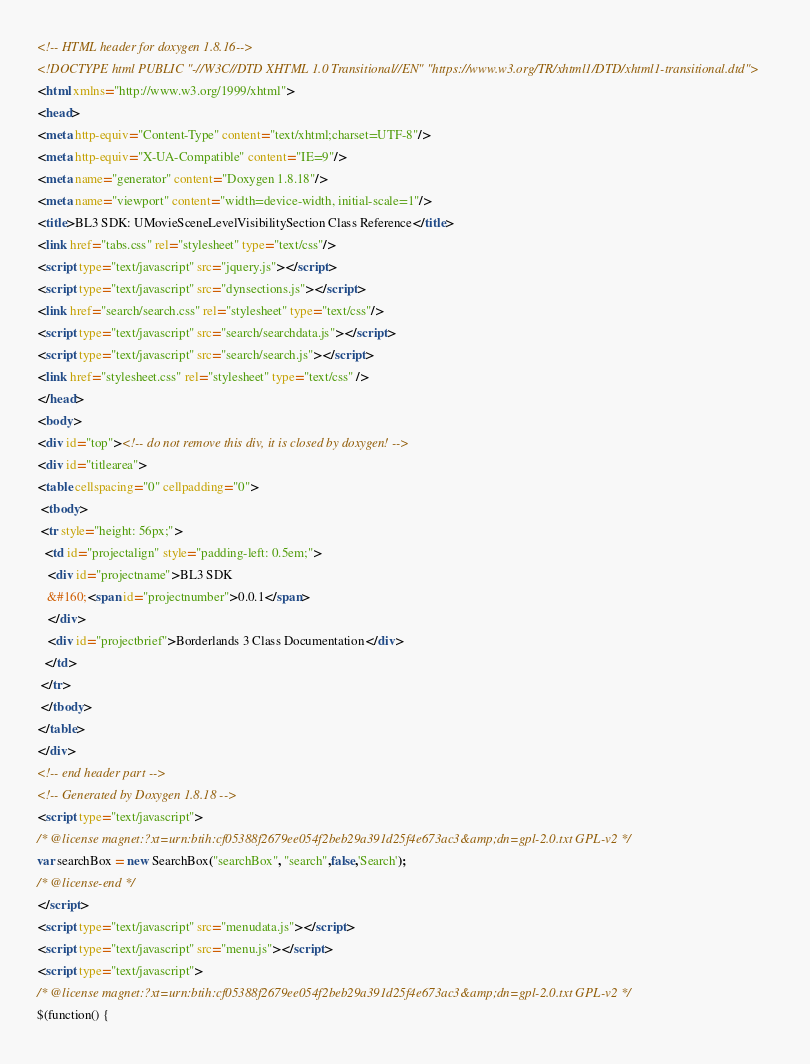<code> <loc_0><loc_0><loc_500><loc_500><_HTML_><!-- HTML header for doxygen 1.8.16-->
<!DOCTYPE html PUBLIC "-//W3C//DTD XHTML 1.0 Transitional//EN" "https://www.w3.org/TR/xhtml1/DTD/xhtml1-transitional.dtd">
<html xmlns="http://www.w3.org/1999/xhtml">
<head>
<meta http-equiv="Content-Type" content="text/xhtml;charset=UTF-8"/>
<meta http-equiv="X-UA-Compatible" content="IE=9"/>
<meta name="generator" content="Doxygen 1.8.18"/>
<meta name="viewport" content="width=device-width, initial-scale=1"/>
<title>BL3 SDK: UMovieSceneLevelVisibilitySection Class Reference</title>
<link href="tabs.css" rel="stylesheet" type="text/css"/>
<script type="text/javascript" src="jquery.js"></script>
<script type="text/javascript" src="dynsections.js"></script>
<link href="search/search.css" rel="stylesheet" type="text/css"/>
<script type="text/javascript" src="search/searchdata.js"></script>
<script type="text/javascript" src="search/search.js"></script>
<link href="stylesheet.css" rel="stylesheet" type="text/css" />
</head>
<body>
<div id="top"><!-- do not remove this div, it is closed by doxygen! -->
<div id="titlearea">
<table cellspacing="0" cellpadding="0">
 <tbody>
 <tr style="height: 56px;">
  <td id="projectalign" style="padding-left: 0.5em;">
   <div id="projectname">BL3 SDK
   &#160;<span id="projectnumber">0.0.1</span>
   </div>
   <div id="projectbrief">Borderlands 3 Class Documentation</div>
  </td>
 </tr>
 </tbody>
</table>
</div>
<!-- end header part -->
<!-- Generated by Doxygen 1.8.18 -->
<script type="text/javascript">
/* @license magnet:?xt=urn:btih:cf05388f2679ee054f2beb29a391d25f4e673ac3&amp;dn=gpl-2.0.txt GPL-v2 */
var searchBox = new SearchBox("searchBox", "search",false,'Search');
/* @license-end */
</script>
<script type="text/javascript" src="menudata.js"></script>
<script type="text/javascript" src="menu.js"></script>
<script type="text/javascript">
/* @license magnet:?xt=urn:btih:cf05388f2679ee054f2beb29a391d25f4e673ac3&amp;dn=gpl-2.0.txt GPL-v2 */
$(function() {</code> 